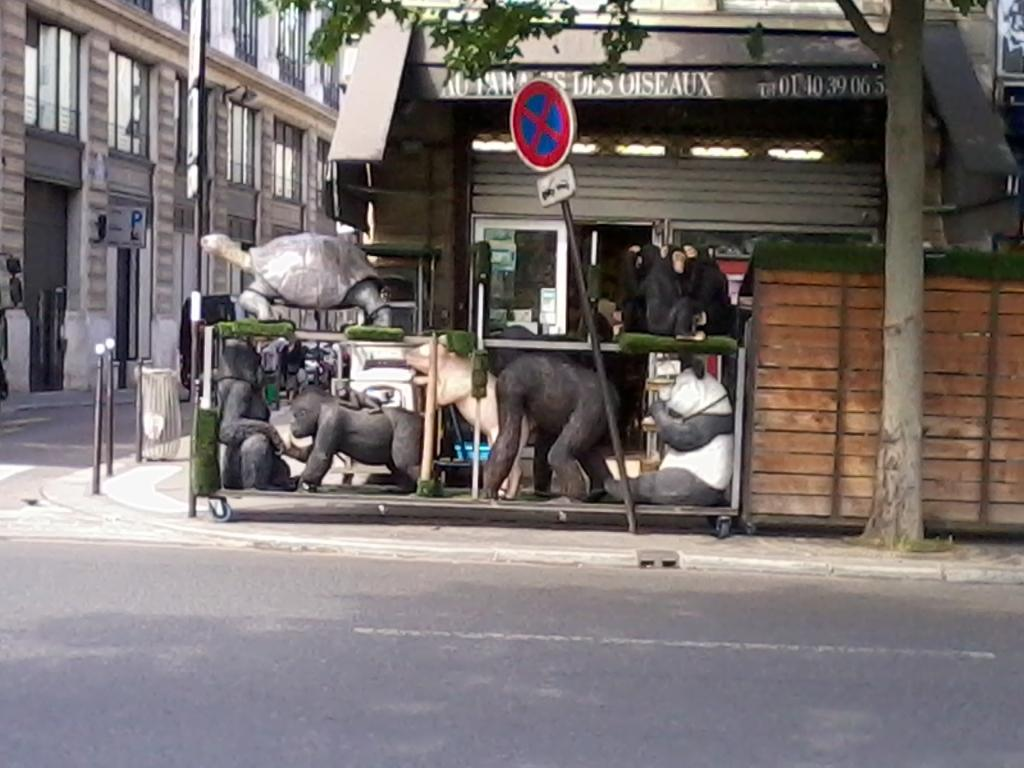What type of pathway is visible in the image? There is a road in the image. What type of structures can be seen in the image? There are statues and buildings in the image. What type of vegetation is on the right side of the image? There is a tree on the right side of the image. What safety feature is present in the image? There is a caution pole in the image. What type of clock is hanging on the tree in the image? There is no clock present in the image; it features a tree, a road, statues, buildings, and a caution pole. What color is the button on the statue in the image? There is no button present on any of the statues in the image. 